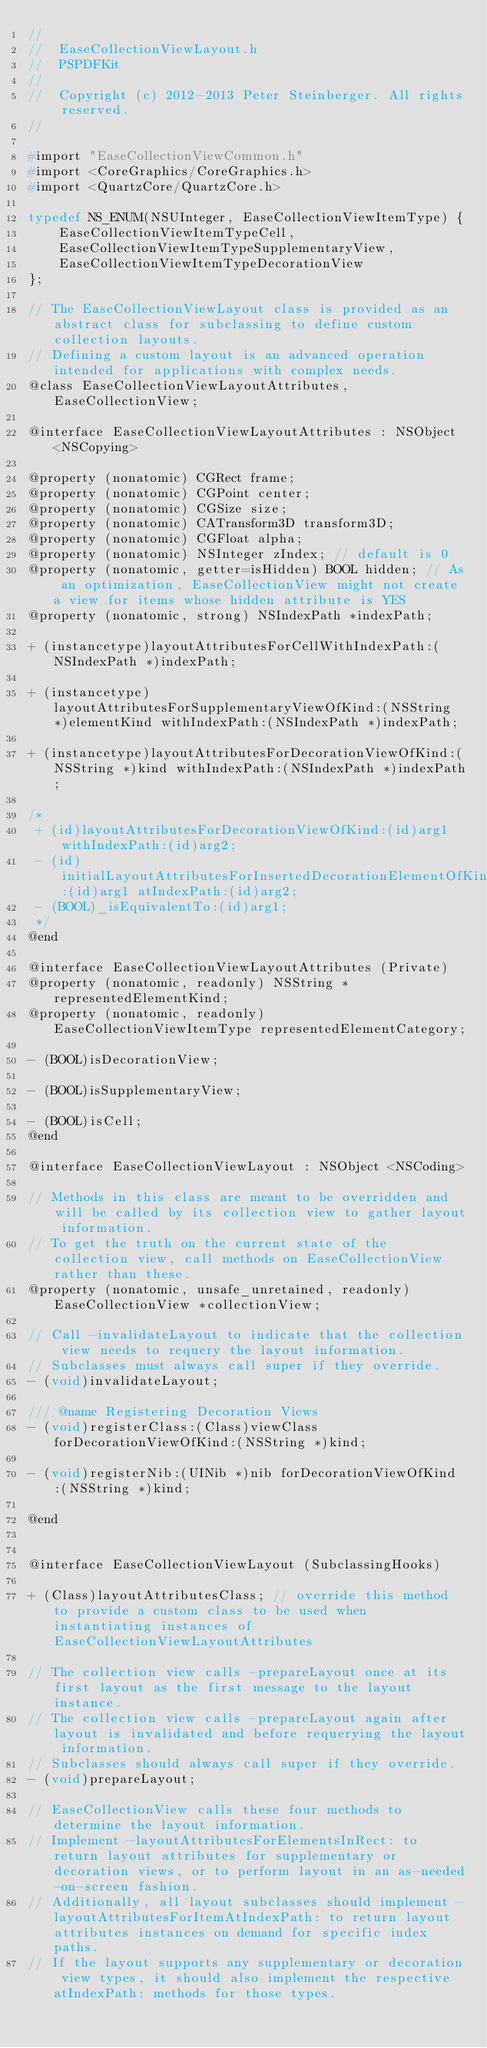Convert code to text. <code><loc_0><loc_0><loc_500><loc_500><_C_>//
//  EaseCollectionViewLayout.h
//  PSPDFKit
//
//  Copyright (c) 2012-2013 Peter Steinberger. All rights reserved.
//

#import "EaseCollectionViewCommon.h"
#import <CoreGraphics/CoreGraphics.h>
#import <QuartzCore/QuartzCore.h>

typedef NS_ENUM(NSUInteger, EaseCollectionViewItemType) {
    EaseCollectionViewItemTypeCell,
    EaseCollectionViewItemTypeSupplementaryView,
    EaseCollectionViewItemTypeDecorationView
};

// The EaseCollectionViewLayout class is provided as an abstract class for subclassing to define custom collection layouts.
// Defining a custom layout is an advanced operation intended for applications with complex needs.
@class EaseCollectionViewLayoutAttributes, EaseCollectionView;

@interface EaseCollectionViewLayoutAttributes : NSObject <NSCopying>

@property (nonatomic) CGRect frame;
@property (nonatomic) CGPoint center;
@property (nonatomic) CGSize size;
@property (nonatomic) CATransform3D transform3D;
@property (nonatomic) CGFloat alpha;
@property (nonatomic) NSInteger zIndex; // default is 0
@property (nonatomic, getter=isHidden) BOOL hidden; // As an optimization, EaseCollectionView might not create a view for items whose hidden attribute is YES
@property (nonatomic, strong) NSIndexPath *indexPath;

+ (instancetype)layoutAttributesForCellWithIndexPath:(NSIndexPath *)indexPath;

+ (instancetype)layoutAttributesForSupplementaryViewOfKind:(NSString *)elementKind withIndexPath:(NSIndexPath *)indexPath;

+ (instancetype)layoutAttributesForDecorationViewOfKind:(NSString *)kind withIndexPath:(NSIndexPath *)indexPath;

/*
 + (id)layoutAttributesForDecorationViewOfKind:(id)arg1 withIndexPath:(id)arg2;
 - (id)initialLayoutAttributesForInsertedDecorationElementOfKind:(id)arg1 atIndexPath:(id)arg2;
 - (BOOL)_isEquivalentTo:(id)arg1;
 */
@end

@interface EaseCollectionViewLayoutAttributes (Private)
@property (nonatomic, readonly) NSString *representedElementKind;
@property (nonatomic, readonly) EaseCollectionViewItemType representedElementCategory;

- (BOOL)isDecorationView;

- (BOOL)isSupplementaryView;

- (BOOL)isCell;
@end

@interface EaseCollectionViewLayout : NSObject <NSCoding>

// Methods in this class are meant to be overridden and will be called by its collection view to gather layout information.
// To get the truth on the current state of the collection view, call methods on EaseCollectionView rather than these.
@property (nonatomic, unsafe_unretained, readonly) EaseCollectionView *collectionView;

// Call -invalidateLayout to indicate that the collection view needs to requery the layout information.
// Subclasses must always call super if they override.
- (void)invalidateLayout;

/// @name Registering Decoration Views
- (void)registerClass:(Class)viewClass forDecorationViewOfKind:(NSString *)kind;

- (void)registerNib:(UINib *)nib forDecorationViewOfKind:(NSString *)kind;

@end


@interface EaseCollectionViewLayout (SubclassingHooks)

+ (Class)layoutAttributesClass; // override this method to provide a custom class to be used when instantiating instances of EaseCollectionViewLayoutAttributes

// The collection view calls -prepareLayout once at its first layout as the first message to the layout instance.
// The collection view calls -prepareLayout again after layout is invalidated and before requerying the layout information.
// Subclasses should always call super if they override.
- (void)prepareLayout;

// EaseCollectionView calls these four methods to determine the layout information.
// Implement -layoutAttributesForElementsInRect: to return layout attributes for supplementary or decoration views, or to perform layout in an as-needed-on-screen fashion.
// Additionally, all layout subclasses should implement -layoutAttributesForItemAtIndexPath: to return layout attributes instances on demand for specific index paths.
// If the layout supports any supplementary or decoration view types, it should also implement the respective atIndexPath: methods for those types.</code> 